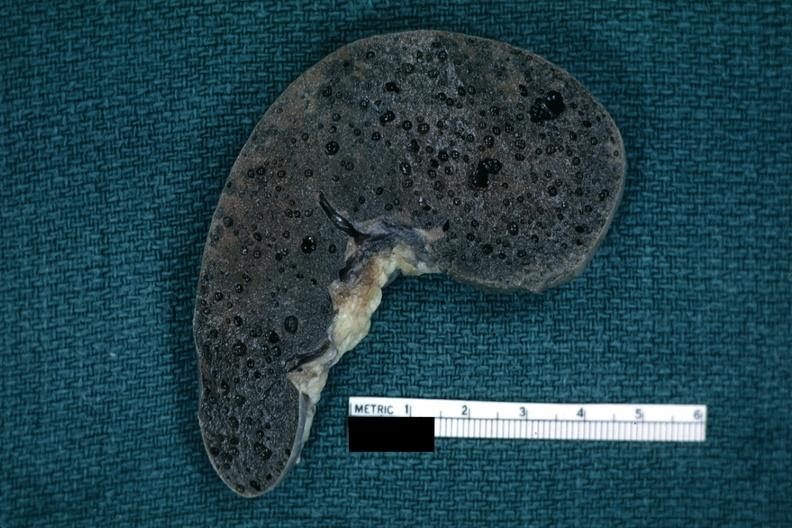s surface present?
Answer the question using a single word or phrase. No 